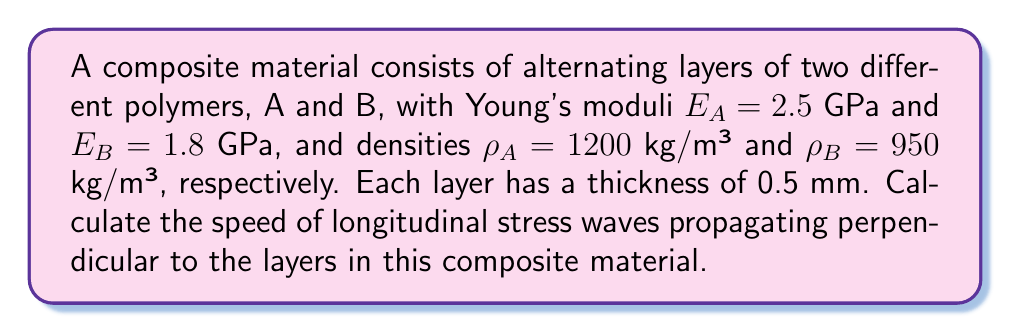Give your solution to this math problem. To solve this problem, we'll follow these steps:

1) For waves propagating perpendicular to the layers, we can use the effective medium theory. The effective elastic modulus ($E_{eff}$) and density ($\rho_{eff}$) are given by:

   $$E_{eff} = \frac{d_A + d_B}{\frac{d_A}{E_A} + \frac{d_B}{E_B}}$$

   $$\rho_{eff} = \frac{\rho_A d_A + \rho_B d_B}{d_A + d_B}$$

   where $d_A$ and $d_B$ are the thicknesses of layers A and B.

2) Given $d_A = d_B = 0.5$ mm, calculate $E_{eff}$:

   $$E_{eff} = \frac{0.5 + 0.5}{\frac{0.5}{2.5} + \frac{0.5}{1.8}} = \frac{1}{\frac{0.2}{2.5} + \frac{0.2778}{1.8}} = 2.1053 \text{ GPa}$$

3) Calculate $\rho_{eff}$:

   $$\rho_{eff} = \frac{1200 \cdot 0.5 + 950 \cdot 0.5}{0.5 + 0.5} = 1075 \text{ kg/m³}$$

4) The speed of longitudinal stress waves in a material is given by:

   $$v = \sqrt{\frac{E}{\rho}}$$

5) Substitute the effective values:

   $$v = \sqrt{\frac{E_{eff}}{\rho_{eff}}} = \sqrt{\frac{2.1053 \cdot 10^9}{1075}} = 1400.9 \text{ m/s}$$
Answer: 1400.9 m/s 